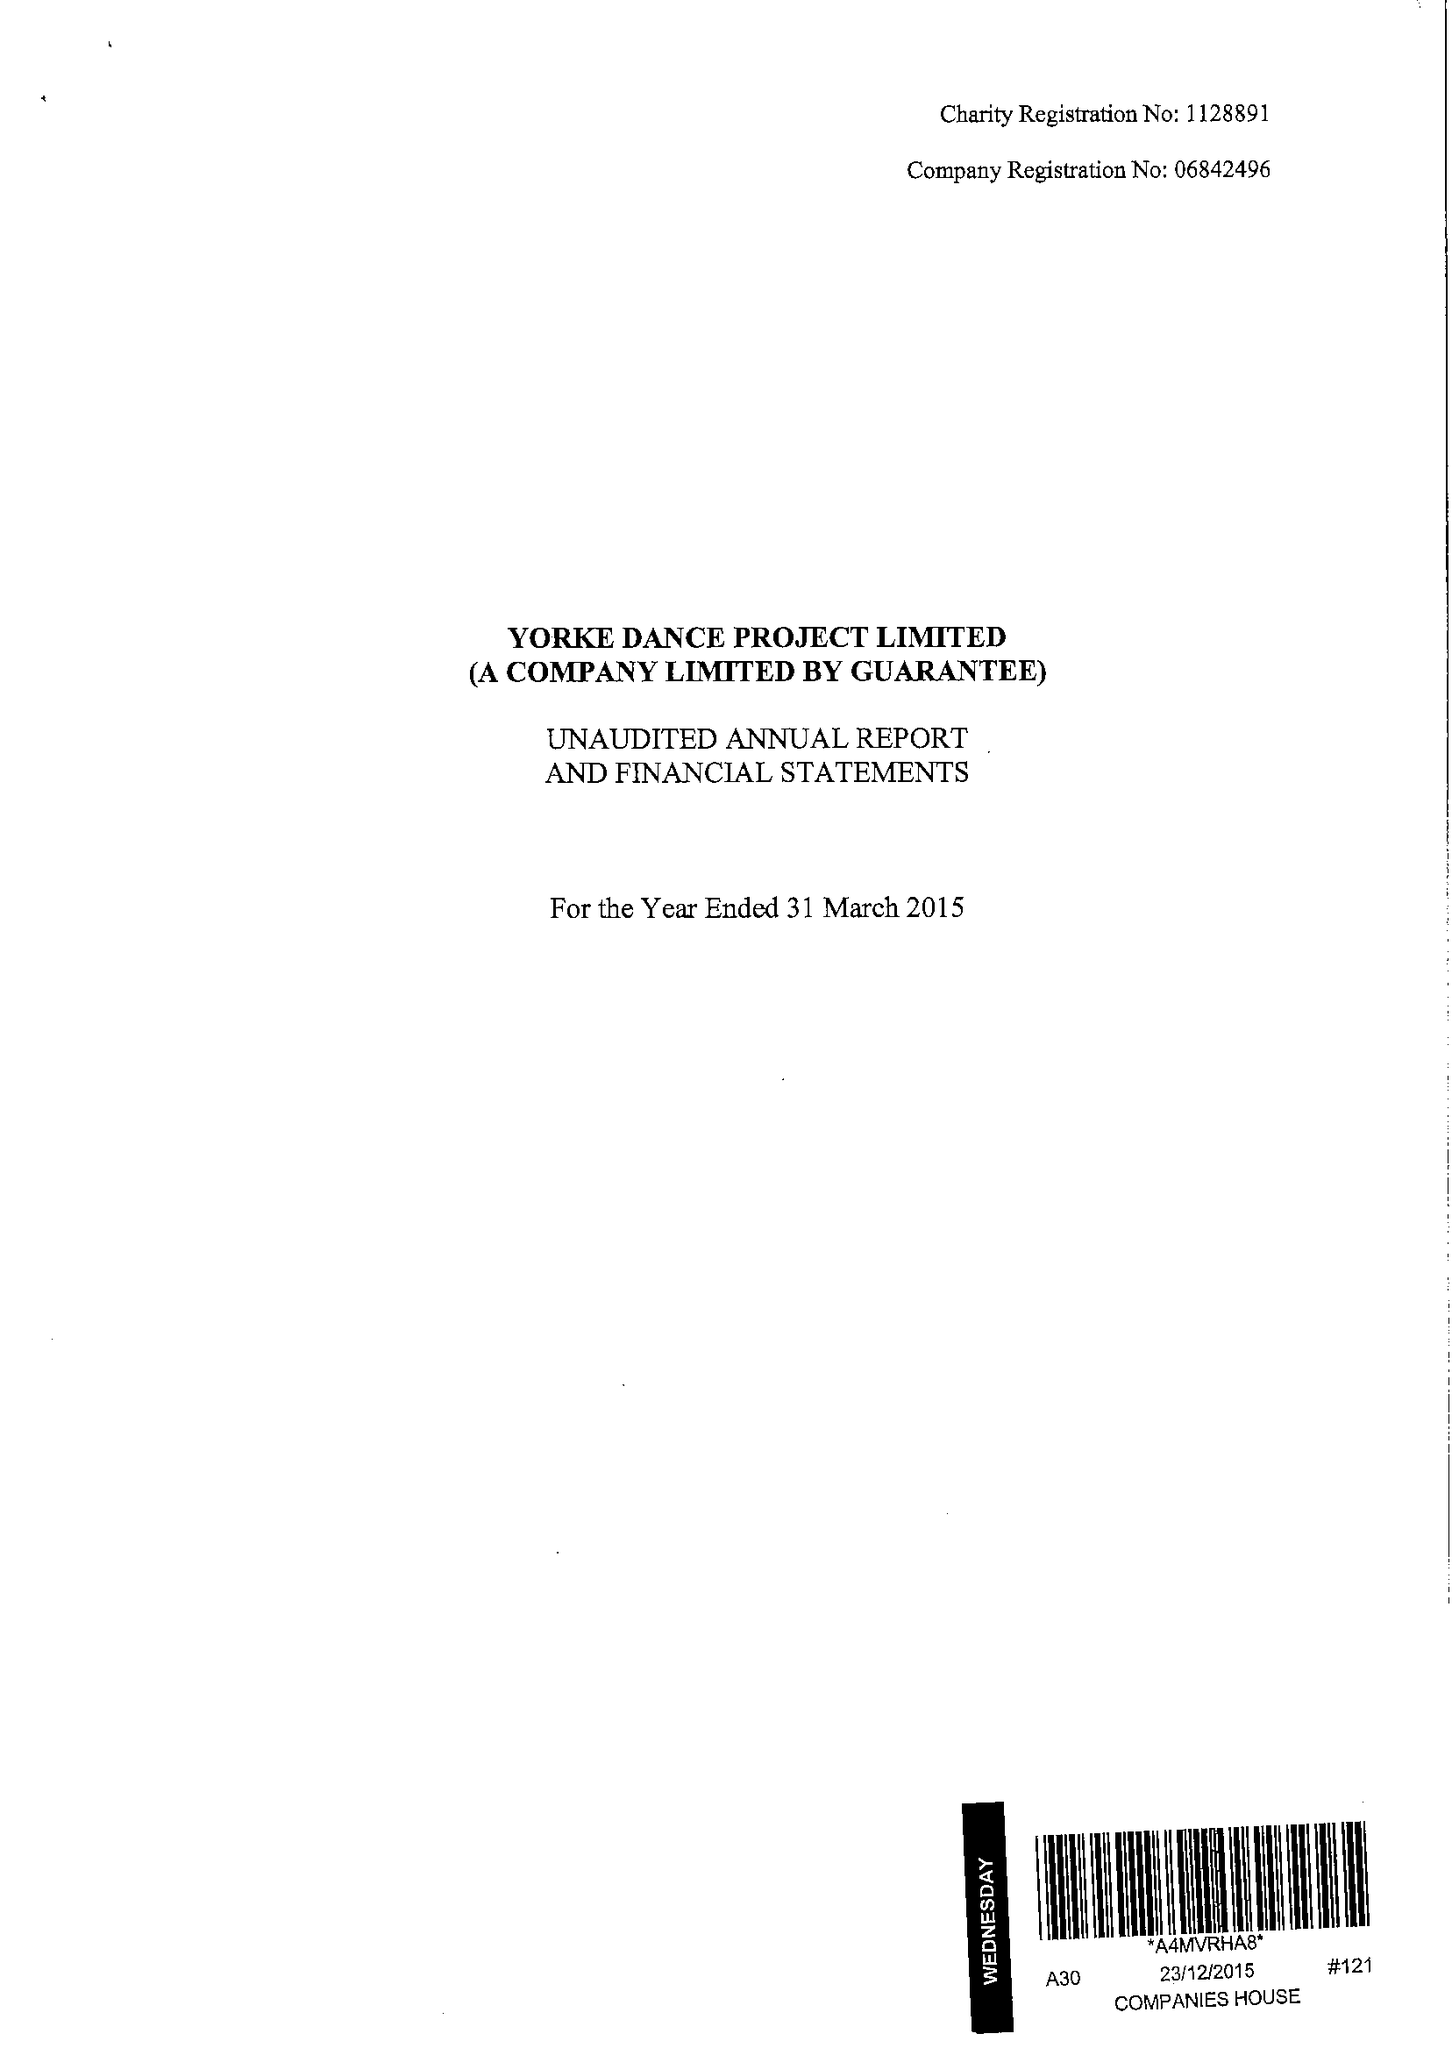What is the value for the income_annually_in_british_pounds?
Answer the question using a single word or phrase. 122856.00 